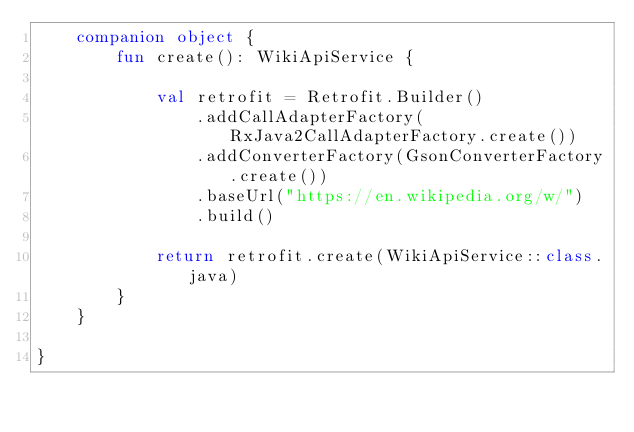<code> <loc_0><loc_0><loc_500><loc_500><_Kotlin_>    companion object {
        fun create(): WikiApiService {

            val retrofit = Retrofit.Builder()
                .addCallAdapterFactory(RxJava2CallAdapterFactory.create())
                .addConverterFactory(GsonConverterFactory.create())
                .baseUrl("https://en.wikipedia.org/w/")
                .build()

            return retrofit.create(WikiApiService::class.java)
        }
    }

}</code> 